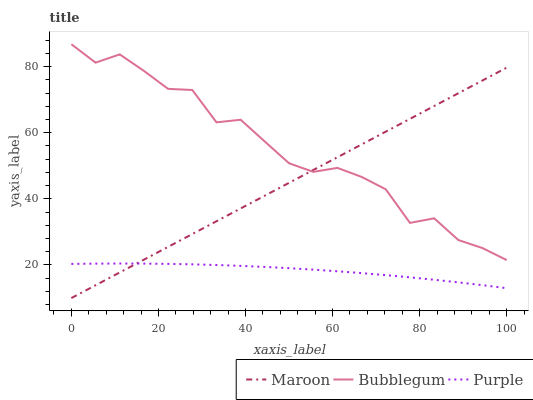Does Maroon have the minimum area under the curve?
Answer yes or no. No. Does Maroon have the maximum area under the curve?
Answer yes or no. No. Is Bubblegum the smoothest?
Answer yes or no. No. Is Maroon the roughest?
Answer yes or no. No. Does Bubblegum have the lowest value?
Answer yes or no. No. Does Maroon have the highest value?
Answer yes or no. No. Is Purple less than Bubblegum?
Answer yes or no. Yes. Is Bubblegum greater than Purple?
Answer yes or no. Yes. Does Purple intersect Bubblegum?
Answer yes or no. No. 